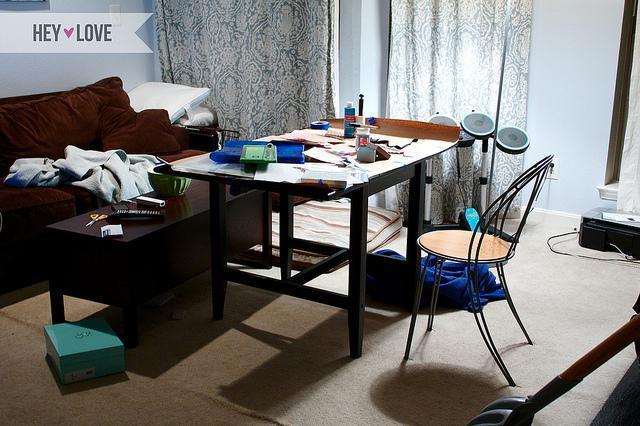How many motorcycle do you see?
Give a very brief answer. 0. 